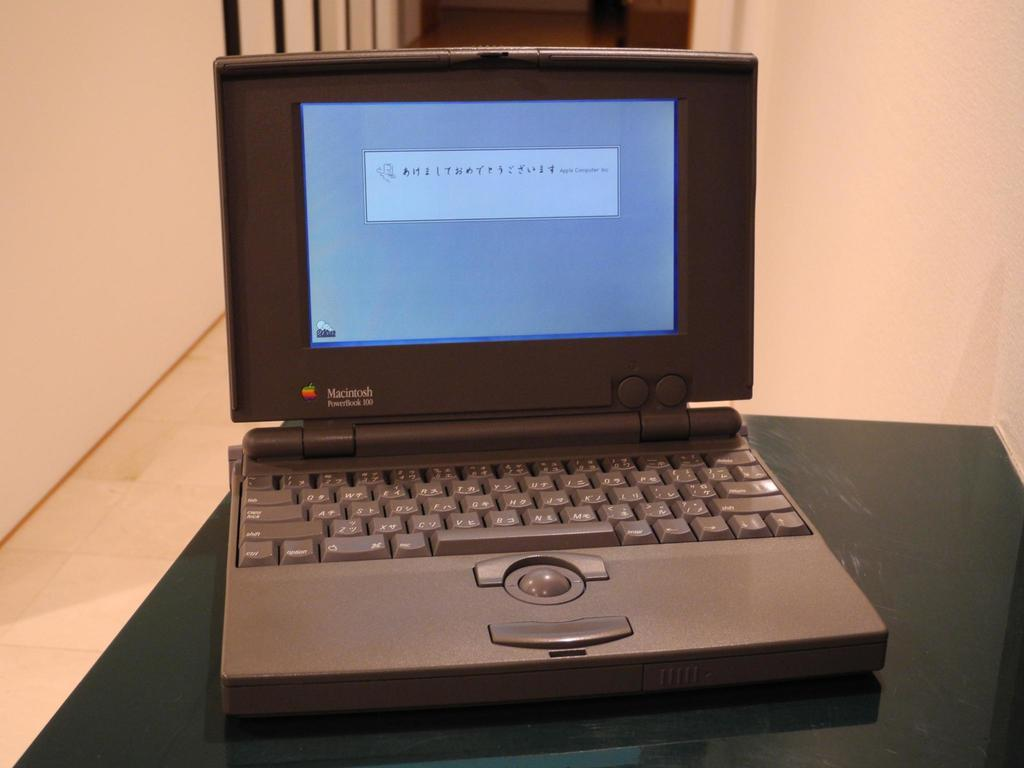What is the main piece of furniture in the image? There is a table in the image. What is placed on the table? There is a laptop on the table. What can be seen in the background of the image? There is a wall in the background of the image. What type of lace is draped over the laptop in the image? There is no lace present in the image; the laptop is not covered or draped with any fabric. 